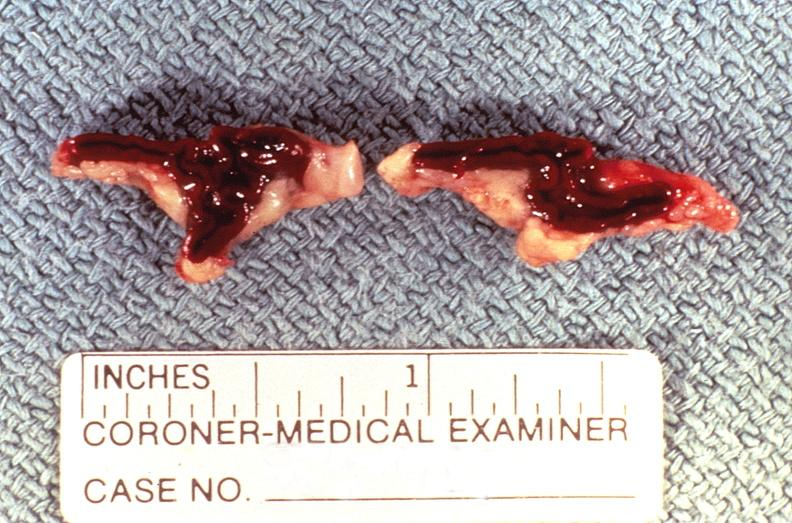where does this belong to?
Answer the question using a single word or phrase. Endocrine system 